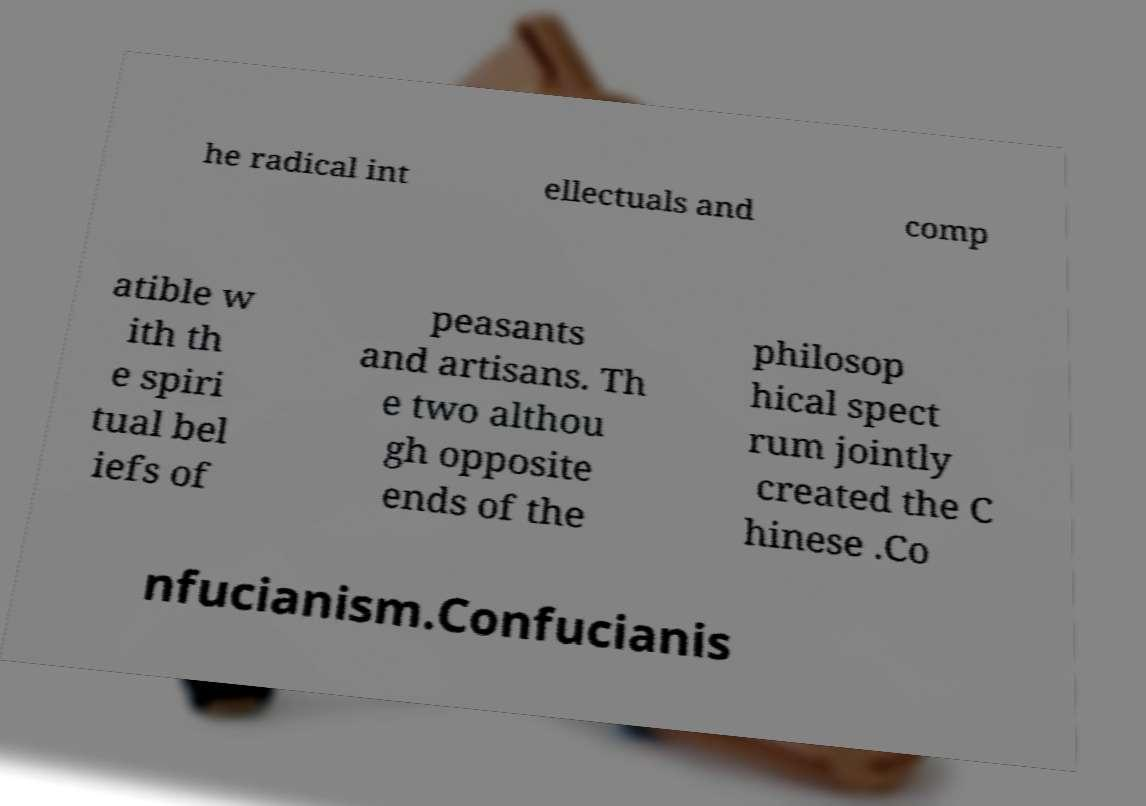Could you assist in decoding the text presented in this image and type it out clearly? he radical int ellectuals and comp atible w ith th e spiri tual bel iefs of peasants and artisans. Th e two althou gh opposite ends of the philosop hical spect rum jointly created the C hinese .Co nfucianism.Confucianis 